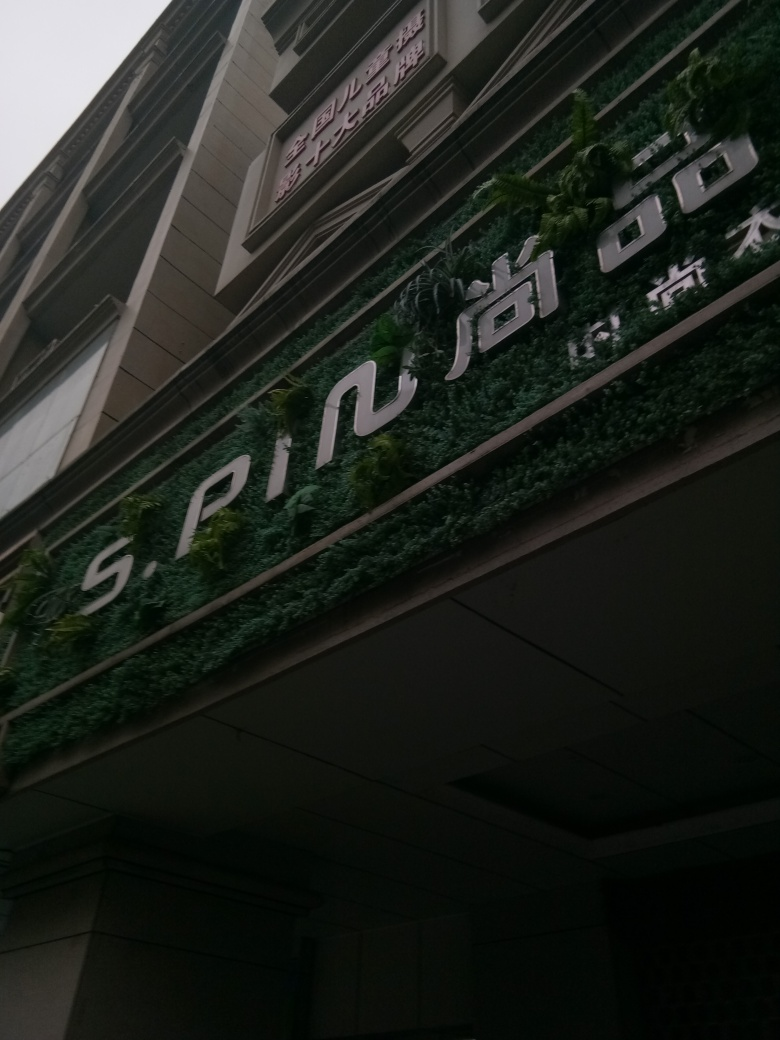What is preserved in the details and textures of the main building's entrance? The main building's entrance features a modern facade accented with a mix of materials, including signage with prominent lettering set against a backdrop of lush vertical garden. The textural contrast between the architectural elements and the greenery creates a visually appealing interplay that combines natural and built environments. However, the image quality limits detailed assessment. 